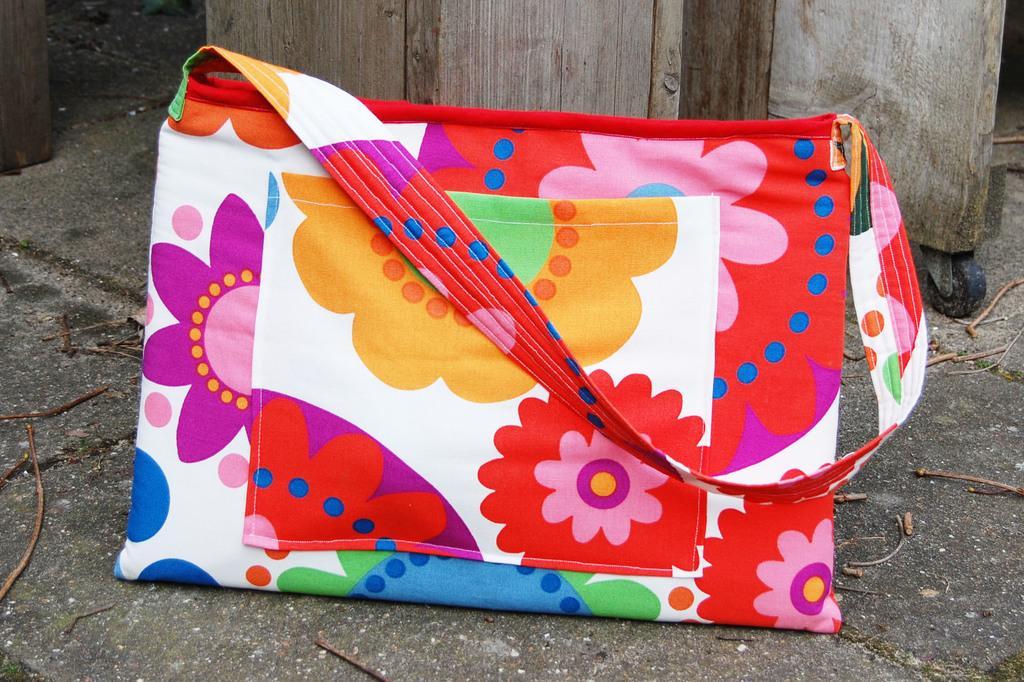Please provide a concise description of this image. There is a bag which is designed with the flowers in different colors. And this is floor. 